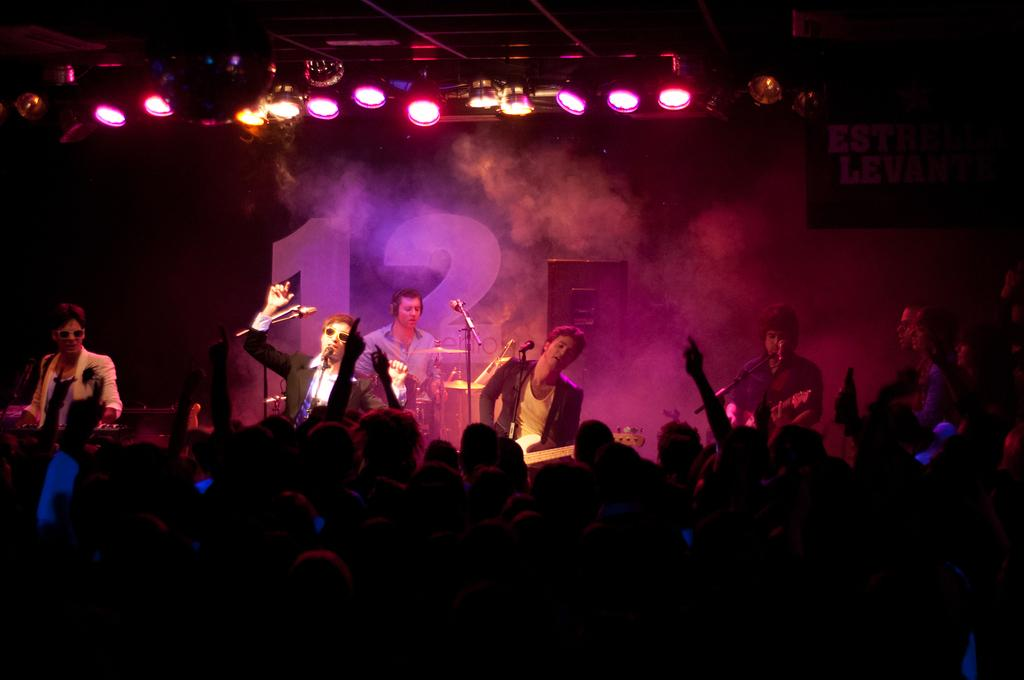What is the main subject of the image? The main subject of the image is a group of people. What are the people in the image doing? The people are standing and holding microphones. What else can be seen in the image besides the people? There are lights visible in the image. Can you describe the position of the people in the image? The group of people is standing. What type of pollution can be seen in the image? There is no pollution visible in the image. Can you tell me what advice the ant is giving to the group of people in the image? There is no ant present in the image, so it cannot provide any advice. 